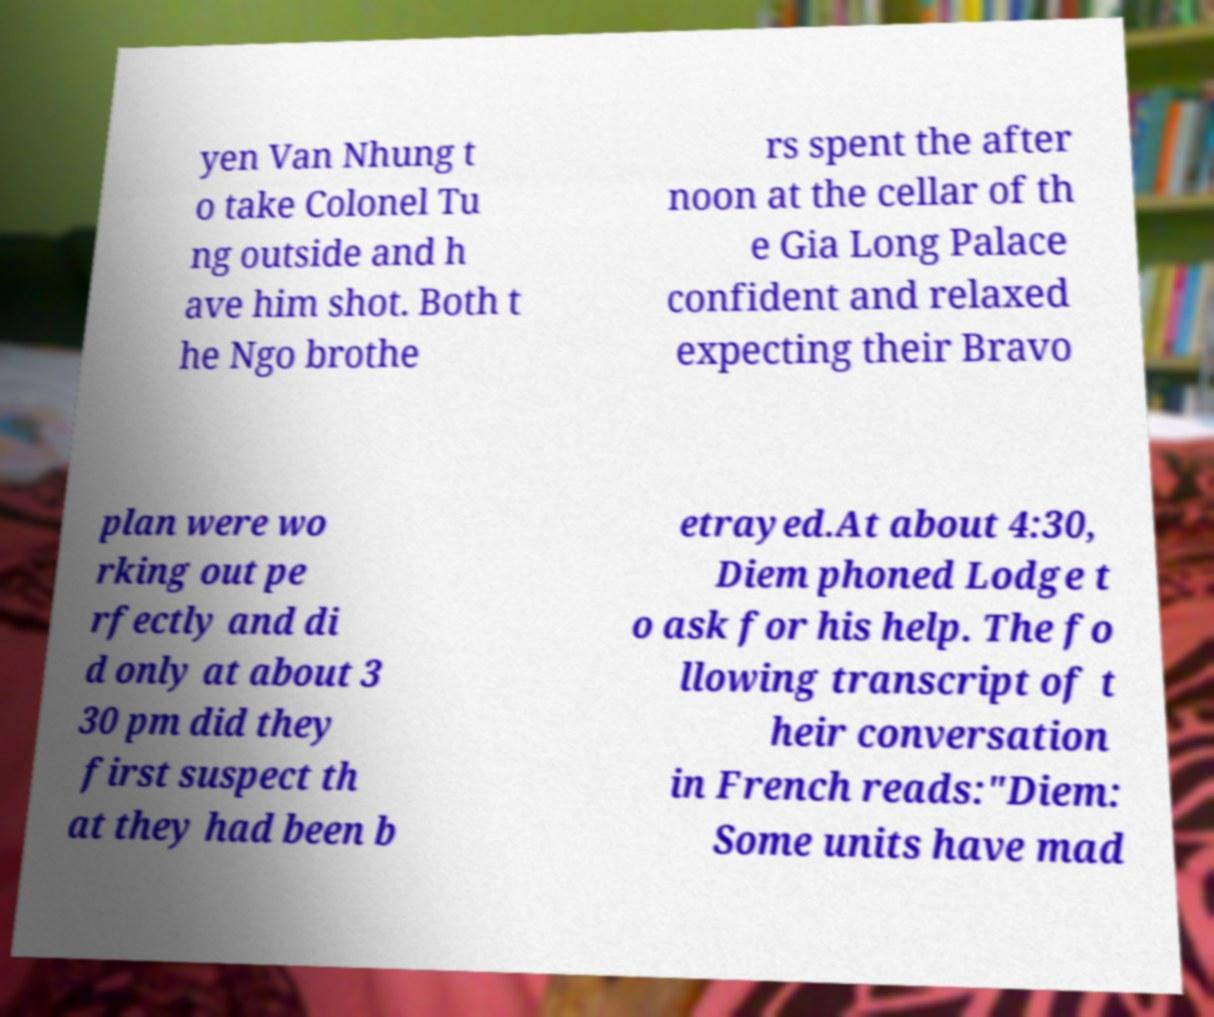What messages or text are displayed in this image? I need them in a readable, typed format. yen Van Nhung t o take Colonel Tu ng outside and h ave him shot. Both t he Ngo brothe rs spent the after noon at the cellar of th e Gia Long Palace confident and relaxed expecting their Bravo plan were wo rking out pe rfectly and di d only at about 3 30 pm did they first suspect th at they had been b etrayed.At about 4:30, Diem phoned Lodge t o ask for his help. The fo llowing transcript of t heir conversation in French reads:"Diem: Some units have mad 